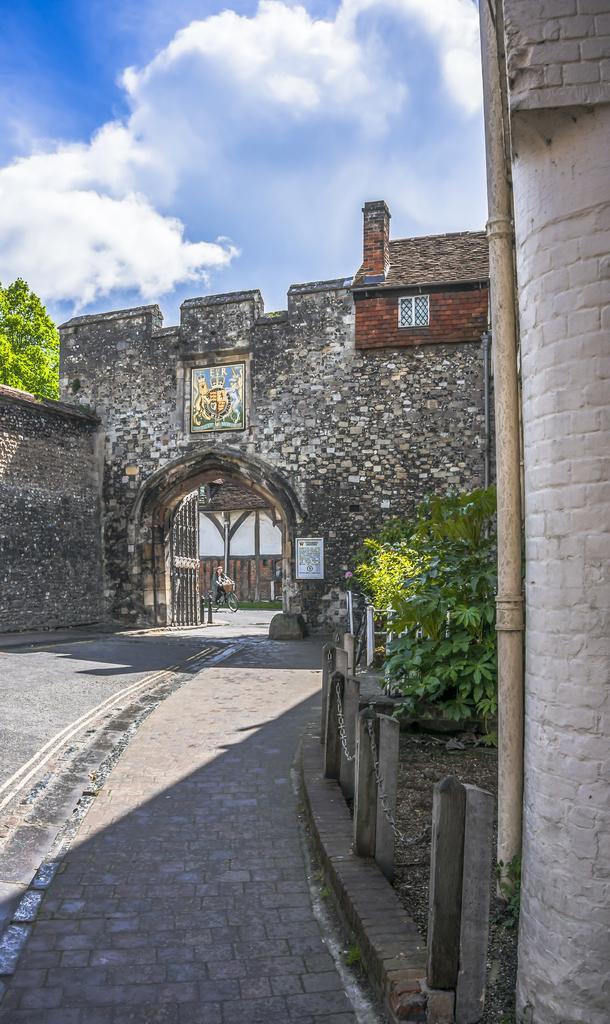In one or two sentences, can you explain what this image depicts? Here in this picture we can see an old monumental building present over a place and in the front we can see an arch like structure with a gate present and we can see a person with a bicycle present on the ground and we can also see plants and trees present over there and we can see clouds in the sky. 